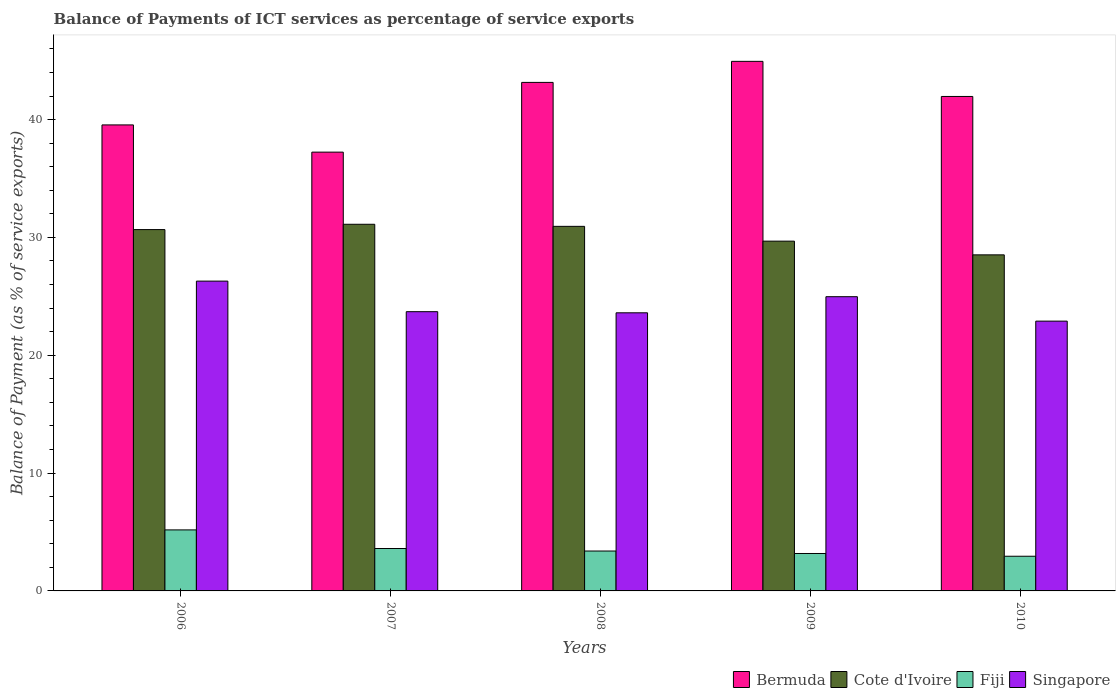How many different coloured bars are there?
Make the answer very short. 4. Are the number of bars on each tick of the X-axis equal?
Your answer should be very brief. Yes. How many bars are there on the 1st tick from the right?
Make the answer very short. 4. What is the label of the 1st group of bars from the left?
Provide a short and direct response. 2006. In how many cases, is the number of bars for a given year not equal to the number of legend labels?
Your answer should be compact. 0. What is the balance of payments of ICT services in Singapore in 2010?
Your response must be concise. 22.9. Across all years, what is the maximum balance of payments of ICT services in Cote d'Ivoire?
Give a very brief answer. 31.12. Across all years, what is the minimum balance of payments of ICT services in Fiji?
Give a very brief answer. 2.94. In which year was the balance of payments of ICT services in Singapore maximum?
Provide a short and direct response. 2006. What is the total balance of payments of ICT services in Fiji in the graph?
Ensure brevity in your answer.  18.28. What is the difference between the balance of payments of ICT services in Fiji in 2007 and that in 2009?
Your answer should be compact. 0.42. What is the difference between the balance of payments of ICT services in Bermuda in 2008 and the balance of payments of ICT services in Cote d'Ivoire in 2010?
Provide a succinct answer. 14.64. What is the average balance of payments of ICT services in Cote d'Ivoire per year?
Give a very brief answer. 30.19. In the year 2006, what is the difference between the balance of payments of ICT services in Cote d'Ivoire and balance of payments of ICT services in Singapore?
Your response must be concise. 4.37. In how many years, is the balance of payments of ICT services in Bermuda greater than 18 %?
Offer a terse response. 5. What is the ratio of the balance of payments of ICT services in Bermuda in 2008 to that in 2010?
Your answer should be very brief. 1.03. Is the balance of payments of ICT services in Singapore in 2006 less than that in 2007?
Give a very brief answer. No. What is the difference between the highest and the second highest balance of payments of ICT services in Cote d'Ivoire?
Offer a terse response. 0.18. What is the difference between the highest and the lowest balance of payments of ICT services in Fiji?
Give a very brief answer. 2.24. In how many years, is the balance of payments of ICT services in Singapore greater than the average balance of payments of ICT services in Singapore taken over all years?
Your response must be concise. 2. Is it the case that in every year, the sum of the balance of payments of ICT services in Singapore and balance of payments of ICT services in Bermuda is greater than the sum of balance of payments of ICT services in Cote d'Ivoire and balance of payments of ICT services in Fiji?
Offer a terse response. Yes. What does the 2nd bar from the left in 2009 represents?
Make the answer very short. Cote d'Ivoire. What does the 3rd bar from the right in 2007 represents?
Provide a short and direct response. Cote d'Ivoire. Is it the case that in every year, the sum of the balance of payments of ICT services in Fiji and balance of payments of ICT services in Singapore is greater than the balance of payments of ICT services in Cote d'Ivoire?
Ensure brevity in your answer.  No. Are all the bars in the graph horizontal?
Your response must be concise. No. What is the difference between two consecutive major ticks on the Y-axis?
Offer a very short reply. 10. Are the values on the major ticks of Y-axis written in scientific E-notation?
Make the answer very short. No. Does the graph contain any zero values?
Your response must be concise. No. Where does the legend appear in the graph?
Your response must be concise. Bottom right. How are the legend labels stacked?
Make the answer very short. Horizontal. What is the title of the graph?
Offer a very short reply. Balance of Payments of ICT services as percentage of service exports. What is the label or title of the X-axis?
Provide a succinct answer. Years. What is the label or title of the Y-axis?
Your response must be concise. Balance of Payment (as % of service exports). What is the Balance of Payment (as % of service exports) of Bermuda in 2006?
Offer a terse response. 39.55. What is the Balance of Payment (as % of service exports) of Cote d'Ivoire in 2006?
Your answer should be very brief. 30.67. What is the Balance of Payment (as % of service exports) of Fiji in 2006?
Provide a succinct answer. 5.18. What is the Balance of Payment (as % of service exports) of Singapore in 2006?
Offer a terse response. 26.29. What is the Balance of Payment (as % of service exports) of Bermuda in 2007?
Give a very brief answer. 37.24. What is the Balance of Payment (as % of service exports) of Cote d'Ivoire in 2007?
Offer a terse response. 31.12. What is the Balance of Payment (as % of service exports) in Fiji in 2007?
Provide a succinct answer. 3.6. What is the Balance of Payment (as % of service exports) of Singapore in 2007?
Keep it short and to the point. 23.7. What is the Balance of Payment (as % of service exports) of Bermuda in 2008?
Provide a short and direct response. 43.16. What is the Balance of Payment (as % of service exports) in Cote d'Ivoire in 2008?
Offer a terse response. 30.94. What is the Balance of Payment (as % of service exports) of Fiji in 2008?
Keep it short and to the point. 3.39. What is the Balance of Payment (as % of service exports) of Singapore in 2008?
Give a very brief answer. 23.6. What is the Balance of Payment (as % of service exports) in Bermuda in 2009?
Ensure brevity in your answer.  44.94. What is the Balance of Payment (as % of service exports) in Cote d'Ivoire in 2009?
Your answer should be very brief. 29.68. What is the Balance of Payment (as % of service exports) in Fiji in 2009?
Give a very brief answer. 3.18. What is the Balance of Payment (as % of service exports) of Singapore in 2009?
Your answer should be compact. 24.97. What is the Balance of Payment (as % of service exports) in Bermuda in 2010?
Offer a terse response. 41.96. What is the Balance of Payment (as % of service exports) in Cote d'Ivoire in 2010?
Make the answer very short. 28.52. What is the Balance of Payment (as % of service exports) in Fiji in 2010?
Your response must be concise. 2.94. What is the Balance of Payment (as % of service exports) of Singapore in 2010?
Provide a succinct answer. 22.9. Across all years, what is the maximum Balance of Payment (as % of service exports) in Bermuda?
Provide a short and direct response. 44.94. Across all years, what is the maximum Balance of Payment (as % of service exports) in Cote d'Ivoire?
Ensure brevity in your answer.  31.12. Across all years, what is the maximum Balance of Payment (as % of service exports) in Fiji?
Give a very brief answer. 5.18. Across all years, what is the maximum Balance of Payment (as % of service exports) of Singapore?
Your answer should be compact. 26.29. Across all years, what is the minimum Balance of Payment (as % of service exports) in Bermuda?
Make the answer very short. 37.24. Across all years, what is the minimum Balance of Payment (as % of service exports) of Cote d'Ivoire?
Give a very brief answer. 28.52. Across all years, what is the minimum Balance of Payment (as % of service exports) of Fiji?
Your answer should be compact. 2.94. Across all years, what is the minimum Balance of Payment (as % of service exports) of Singapore?
Offer a terse response. 22.9. What is the total Balance of Payment (as % of service exports) of Bermuda in the graph?
Give a very brief answer. 206.85. What is the total Balance of Payment (as % of service exports) of Cote d'Ivoire in the graph?
Make the answer very short. 150.93. What is the total Balance of Payment (as % of service exports) of Fiji in the graph?
Ensure brevity in your answer.  18.28. What is the total Balance of Payment (as % of service exports) in Singapore in the graph?
Keep it short and to the point. 121.46. What is the difference between the Balance of Payment (as % of service exports) of Bermuda in 2006 and that in 2007?
Provide a succinct answer. 2.31. What is the difference between the Balance of Payment (as % of service exports) of Cote d'Ivoire in 2006 and that in 2007?
Your answer should be compact. -0.45. What is the difference between the Balance of Payment (as % of service exports) of Fiji in 2006 and that in 2007?
Your response must be concise. 1.58. What is the difference between the Balance of Payment (as % of service exports) of Singapore in 2006 and that in 2007?
Provide a succinct answer. 2.59. What is the difference between the Balance of Payment (as % of service exports) in Bermuda in 2006 and that in 2008?
Keep it short and to the point. -3.61. What is the difference between the Balance of Payment (as % of service exports) in Cote d'Ivoire in 2006 and that in 2008?
Offer a terse response. -0.27. What is the difference between the Balance of Payment (as % of service exports) of Fiji in 2006 and that in 2008?
Make the answer very short. 1.79. What is the difference between the Balance of Payment (as % of service exports) of Singapore in 2006 and that in 2008?
Your answer should be compact. 2.69. What is the difference between the Balance of Payment (as % of service exports) of Bermuda in 2006 and that in 2009?
Keep it short and to the point. -5.39. What is the difference between the Balance of Payment (as % of service exports) of Cote d'Ivoire in 2006 and that in 2009?
Provide a succinct answer. 0.98. What is the difference between the Balance of Payment (as % of service exports) in Fiji in 2006 and that in 2009?
Your answer should be compact. 2. What is the difference between the Balance of Payment (as % of service exports) in Singapore in 2006 and that in 2009?
Provide a short and direct response. 1.32. What is the difference between the Balance of Payment (as % of service exports) of Bermuda in 2006 and that in 2010?
Your response must be concise. -2.41. What is the difference between the Balance of Payment (as % of service exports) of Cote d'Ivoire in 2006 and that in 2010?
Provide a succinct answer. 2.14. What is the difference between the Balance of Payment (as % of service exports) in Fiji in 2006 and that in 2010?
Offer a terse response. 2.24. What is the difference between the Balance of Payment (as % of service exports) of Singapore in 2006 and that in 2010?
Keep it short and to the point. 3.4. What is the difference between the Balance of Payment (as % of service exports) in Bermuda in 2007 and that in 2008?
Give a very brief answer. -5.92. What is the difference between the Balance of Payment (as % of service exports) of Cote d'Ivoire in 2007 and that in 2008?
Your answer should be compact. 0.18. What is the difference between the Balance of Payment (as % of service exports) in Fiji in 2007 and that in 2008?
Keep it short and to the point. 0.21. What is the difference between the Balance of Payment (as % of service exports) in Singapore in 2007 and that in 2008?
Keep it short and to the point. 0.1. What is the difference between the Balance of Payment (as % of service exports) in Bermuda in 2007 and that in 2009?
Your response must be concise. -7.7. What is the difference between the Balance of Payment (as % of service exports) in Cote d'Ivoire in 2007 and that in 2009?
Offer a very short reply. 1.43. What is the difference between the Balance of Payment (as % of service exports) of Fiji in 2007 and that in 2009?
Your answer should be compact. 0.42. What is the difference between the Balance of Payment (as % of service exports) of Singapore in 2007 and that in 2009?
Provide a short and direct response. -1.27. What is the difference between the Balance of Payment (as % of service exports) in Bermuda in 2007 and that in 2010?
Give a very brief answer. -4.73. What is the difference between the Balance of Payment (as % of service exports) in Cote d'Ivoire in 2007 and that in 2010?
Ensure brevity in your answer.  2.6. What is the difference between the Balance of Payment (as % of service exports) in Fiji in 2007 and that in 2010?
Provide a succinct answer. 0.66. What is the difference between the Balance of Payment (as % of service exports) of Singapore in 2007 and that in 2010?
Keep it short and to the point. 0.8. What is the difference between the Balance of Payment (as % of service exports) of Bermuda in 2008 and that in 2009?
Make the answer very short. -1.79. What is the difference between the Balance of Payment (as % of service exports) of Cote d'Ivoire in 2008 and that in 2009?
Your answer should be compact. 1.26. What is the difference between the Balance of Payment (as % of service exports) of Fiji in 2008 and that in 2009?
Your response must be concise. 0.21. What is the difference between the Balance of Payment (as % of service exports) in Singapore in 2008 and that in 2009?
Offer a very short reply. -1.37. What is the difference between the Balance of Payment (as % of service exports) in Bermuda in 2008 and that in 2010?
Provide a succinct answer. 1.19. What is the difference between the Balance of Payment (as % of service exports) of Cote d'Ivoire in 2008 and that in 2010?
Your answer should be compact. 2.42. What is the difference between the Balance of Payment (as % of service exports) in Fiji in 2008 and that in 2010?
Provide a succinct answer. 0.44. What is the difference between the Balance of Payment (as % of service exports) in Singapore in 2008 and that in 2010?
Offer a terse response. 0.71. What is the difference between the Balance of Payment (as % of service exports) of Bermuda in 2009 and that in 2010?
Give a very brief answer. 2.98. What is the difference between the Balance of Payment (as % of service exports) in Cote d'Ivoire in 2009 and that in 2010?
Keep it short and to the point. 1.16. What is the difference between the Balance of Payment (as % of service exports) of Fiji in 2009 and that in 2010?
Make the answer very short. 0.23. What is the difference between the Balance of Payment (as % of service exports) in Singapore in 2009 and that in 2010?
Provide a short and direct response. 2.07. What is the difference between the Balance of Payment (as % of service exports) of Bermuda in 2006 and the Balance of Payment (as % of service exports) of Cote d'Ivoire in 2007?
Offer a very short reply. 8.43. What is the difference between the Balance of Payment (as % of service exports) in Bermuda in 2006 and the Balance of Payment (as % of service exports) in Fiji in 2007?
Provide a succinct answer. 35.95. What is the difference between the Balance of Payment (as % of service exports) of Bermuda in 2006 and the Balance of Payment (as % of service exports) of Singapore in 2007?
Give a very brief answer. 15.85. What is the difference between the Balance of Payment (as % of service exports) in Cote d'Ivoire in 2006 and the Balance of Payment (as % of service exports) in Fiji in 2007?
Provide a short and direct response. 27.07. What is the difference between the Balance of Payment (as % of service exports) in Cote d'Ivoire in 2006 and the Balance of Payment (as % of service exports) in Singapore in 2007?
Keep it short and to the point. 6.97. What is the difference between the Balance of Payment (as % of service exports) in Fiji in 2006 and the Balance of Payment (as % of service exports) in Singapore in 2007?
Give a very brief answer. -18.52. What is the difference between the Balance of Payment (as % of service exports) in Bermuda in 2006 and the Balance of Payment (as % of service exports) in Cote d'Ivoire in 2008?
Ensure brevity in your answer.  8.61. What is the difference between the Balance of Payment (as % of service exports) of Bermuda in 2006 and the Balance of Payment (as % of service exports) of Fiji in 2008?
Your answer should be very brief. 36.16. What is the difference between the Balance of Payment (as % of service exports) in Bermuda in 2006 and the Balance of Payment (as % of service exports) in Singapore in 2008?
Provide a succinct answer. 15.95. What is the difference between the Balance of Payment (as % of service exports) of Cote d'Ivoire in 2006 and the Balance of Payment (as % of service exports) of Fiji in 2008?
Offer a very short reply. 27.28. What is the difference between the Balance of Payment (as % of service exports) in Cote d'Ivoire in 2006 and the Balance of Payment (as % of service exports) in Singapore in 2008?
Your answer should be very brief. 7.06. What is the difference between the Balance of Payment (as % of service exports) of Fiji in 2006 and the Balance of Payment (as % of service exports) of Singapore in 2008?
Give a very brief answer. -18.42. What is the difference between the Balance of Payment (as % of service exports) of Bermuda in 2006 and the Balance of Payment (as % of service exports) of Cote d'Ivoire in 2009?
Your answer should be very brief. 9.86. What is the difference between the Balance of Payment (as % of service exports) in Bermuda in 2006 and the Balance of Payment (as % of service exports) in Fiji in 2009?
Provide a short and direct response. 36.37. What is the difference between the Balance of Payment (as % of service exports) of Bermuda in 2006 and the Balance of Payment (as % of service exports) of Singapore in 2009?
Your answer should be compact. 14.58. What is the difference between the Balance of Payment (as % of service exports) of Cote d'Ivoire in 2006 and the Balance of Payment (as % of service exports) of Fiji in 2009?
Provide a short and direct response. 27.49. What is the difference between the Balance of Payment (as % of service exports) in Cote d'Ivoire in 2006 and the Balance of Payment (as % of service exports) in Singapore in 2009?
Your response must be concise. 5.69. What is the difference between the Balance of Payment (as % of service exports) in Fiji in 2006 and the Balance of Payment (as % of service exports) in Singapore in 2009?
Your response must be concise. -19.79. What is the difference between the Balance of Payment (as % of service exports) of Bermuda in 2006 and the Balance of Payment (as % of service exports) of Cote d'Ivoire in 2010?
Your answer should be compact. 11.03. What is the difference between the Balance of Payment (as % of service exports) of Bermuda in 2006 and the Balance of Payment (as % of service exports) of Fiji in 2010?
Offer a very short reply. 36.61. What is the difference between the Balance of Payment (as % of service exports) in Bermuda in 2006 and the Balance of Payment (as % of service exports) in Singapore in 2010?
Provide a short and direct response. 16.65. What is the difference between the Balance of Payment (as % of service exports) of Cote d'Ivoire in 2006 and the Balance of Payment (as % of service exports) of Fiji in 2010?
Provide a short and direct response. 27.72. What is the difference between the Balance of Payment (as % of service exports) in Cote d'Ivoire in 2006 and the Balance of Payment (as % of service exports) in Singapore in 2010?
Offer a terse response. 7.77. What is the difference between the Balance of Payment (as % of service exports) in Fiji in 2006 and the Balance of Payment (as % of service exports) in Singapore in 2010?
Your answer should be compact. -17.72. What is the difference between the Balance of Payment (as % of service exports) of Bermuda in 2007 and the Balance of Payment (as % of service exports) of Cote d'Ivoire in 2008?
Your answer should be compact. 6.3. What is the difference between the Balance of Payment (as % of service exports) of Bermuda in 2007 and the Balance of Payment (as % of service exports) of Fiji in 2008?
Offer a terse response. 33.85. What is the difference between the Balance of Payment (as % of service exports) of Bermuda in 2007 and the Balance of Payment (as % of service exports) of Singapore in 2008?
Your answer should be compact. 13.64. What is the difference between the Balance of Payment (as % of service exports) in Cote d'Ivoire in 2007 and the Balance of Payment (as % of service exports) in Fiji in 2008?
Give a very brief answer. 27.73. What is the difference between the Balance of Payment (as % of service exports) of Cote d'Ivoire in 2007 and the Balance of Payment (as % of service exports) of Singapore in 2008?
Your answer should be compact. 7.51. What is the difference between the Balance of Payment (as % of service exports) in Fiji in 2007 and the Balance of Payment (as % of service exports) in Singapore in 2008?
Ensure brevity in your answer.  -20. What is the difference between the Balance of Payment (as % of service exports) of Bermuda in 2007 and the Balance of Payment (as % of service exports) of Cote d'Ivoire in 2009?
Make the answer very short. 7.55. What is the difference between the Balance of Payment (as % of service exports) of Bermuda in 2007 and the Balance of Payment (as % of service exports) of Fiji in 2009?
Your response must be concise. 34.06. What is the difference between the Balance of Payment (as % of service exports) in Bermuda in 2007 and the Balance of Payment (as % of service exports) in Singapore in 2009?
Give a very brief answer. 12.27. What is the difference between the Balance of Payment (as % of service exports) in Cote d'Ivoire in 2007 and the Balance of Payment (as % of service exports) in Fiji in 2009?
Your answer should be very brief. 27.94. What is the difference between the Balance of Payment (as % of service exports) of Cote d'Ivoire in 2007 and the Balance of Payment (as % of service exports) of Singapore in 2009?
Give a very brief answer. 6.15. What is the difference between the Balance of Payment (as % of service exports) of Fiji in 2007 and the Balance of Payment (as % of service exports) of Singapore in 2009?
Offer a terse response. -21.37. What is the difference between the Balance of Payment (as % of service exports) of Bermuda in 2007 and the Balance of Payment (as % of service exports) of Cote d'Ivoire in 2010?
Offer a very short reply. 8.72. What is the difference between the Balance of Payment (as % of service exports) in Bermuda in 2007 and the Balance of Payment (as % of service exports) in Fiji in 2010?
Offer a terse response. 34.3. What is the difference between the Balance of Payment (as % of service exports) in Bermuda in 2007 and the Balance of Payment (as % of service exports) in Singapore in 2010?
Keep it short and to the point. 14.34. What is the difference between the Balance of Payment (as % of service exports) of Cote d'Ivoire in 2007 and the Balance of Payment (as % of service exports) of Fiji in 2010?
Your answer should be compact. 28.17. What is the difference between the Balance of Payment (as % of service exports) in Cote d'Ivoire in 2007 and the Balance of Payment (as % of service exports) in Singapore in 2010?
Ensure brevity in your answer.  8.22. What is the difference between the Balance of Payment (as % of service exports) of Fiji in 2007 and the Balance of Payment (as % of service exports) of Singapore in 2010?
Offer a terse response. -19.3. What is the difference between the Balance of Payment (as % of service exports) in Bermuda in 2008 and the Balance of Payment (as % of service exports) in Cote d'Ivoire in 2009?
Provide a succinct answer. 13.47. What is the difference between the Balance of Payment (as % of service exports) of Bermuda in 2008 and the Balance of Payment (as % of service exports) of Fiji in 2009?
Offer a terse response. 39.98. What is the difference between the Balance of Payment (as % of service exports) in Bermuda in 2008 and the Balance of Payment (as % of service exports) in Singapore in 2009?
Your answer should be compact. 18.19. What is the difference between the Balance of Payment (as % of service exports) of Cote d'Ivoire in 2008 and the Balance of Payment (as % of service exports) of Fiji in 2009?
Provide a short and direct response. 27.76. What is the difference between the Balance of Payment (as % of service exports) in Cote d'Ivoire in 2008 and the Balance of Payment (as % of service exports) in Singapore in 2009?
Your answer should be very brief. 5.97. What is the difference between the Balance of Payment (as % of service exports) of Fiji in 2008 and the Balance of Payment (as % of service exports) of Singapore in 2009?
Offer a terse response. -21.58. What is the difference between the Balance of Payment (as % of service exports) in Bermuda in 2008 and the Balance of Payment (as % of service exports) in Cote d'Ivoire in 2010?
Your response must be concise. 14.64. What is the difference between the Balance of Payment (as % of service exports) in Bermuda in 2008 and the Balance of Payment (as % of service exports) in Fiji in 2010?
Your answer should be very brief. 40.21. What is the difference between the Balance of Payment (as % of service exports) in Bermuda in 2008 and the Balance of Payment (as % of service exports) in Singapore in 2010?
Your answer should be compact. 20.26. What is the difference between the Balance of Payment (as % of service exports) in Cote d'Ivoire in 2008 and the Balance of Payment (as % of service exports) in Fiji in 2010?
Provide a short and direct response. 28. What is the difference between the Balance of Payment (as % of service exports) of Cote d'Ivoire in 2008 and the Balance of Payment (as % of service exports) of Singapore in 2010?
Ensure brevity in your answer.  8.04. What is the difference between the Balance of Payment (as % of service exports) of Fiji in 2008 and the Balance of Payment (as % of service exports) of Singapore in 2010?
Ensure brevity in your answer.  -19.51. What is the difference between the Balance of Payment (as % of service exports) in Bermuda in 2009 and the Balance of Payment (as % of service exports) in Cote d'Ivoire in 2010?
Offer a terse response. 16.42. What is the difference between the Balance of Payment (as % of service exports) in Bermuda in 2009 and the Balance of Payment (as % of service exports) in Fiji in 2010?
Ensure brevity in your answer.  42. What is the difference between the Balance of Payment (as % of service exports) in Bermuda in 2009 and the Balance of Payment (as % of service exports) in Singapore in 2010?
Offer a very short reply. 22.05. What is the difference between the Balance of Payment (as % of service exports) of Cote d'Ivoire in 2009 and the Balance of Payment (as % of service exports) of Fiji in 2010?
Give a very brief answer. 26.74. What is the difference between the Balance of Payment (as % of service exports) of Cote d'Ivoire in 2009 and the Balance of Payment (as % of service exports) of Singapore in 2010?
Your answer should be compact. 6.79. What is the difference between the Balance of Payment (as % of service exports) in Fiji in 2009 and the Balance of Payment (as % of service exports) in Singapore in 2010?
Make the answer very short. -19.72. What is the average Balance of Payment (as % of service exports) in Bermuda per year?
Offer a terse response. 41.37. What is the average Balance of Payment (as % of service exports) in Cote d'Ivoire per year?
Offer a very short reply. 30.19. What is the average Balance of Payment (as % of service exports) of Fiji per year?
Give a very brief answer. 3.66. What is the average Balance of Payment (as % of service exports) in Singapore per year?
Keep it short and to the point. 24.29. In the year 2006, what is the difference between the Balance of Payment (as % of service exports) of Bermuda and Balance of Payment (as % of service exports) of Cote d'Ivoire?
Ensure brevity in your answer.  8.88. In the year 2006, what is the difference between the Balance of Payment (as % of service exports) of Bermuda and Balance of Payment (as % of service exports) of Fiji?
Offer a very short reply. 34.37. In the year 2006, what is the difference between the Balance of Payment (as % of service exports) in Bermuda and Balance of Payment (as % of service exports) in Singapore?
Provide a succinct answer. 13.26. In the year 2006, what is the difference between the Balance of Payment (as % of service exports) of Cote d'Ivoire and Balance of Payment (as % of service exports) of Fiji?
Give a very brief answer. 25.49. In the year 2006, what is the difference between the Balance of Payment (as % of service exports) of Cote d'Ivoire and Balance of Payment (as % of service exports) of Singapore?
Provide a short and direct response. 4.37. In the year 2006, what is the difference between the Balance of Payment (as % of service exports) in Fiji and Balance of Payment (as % of service exports) in Singapore?
Provide a succinct answer. -21.11. In the year 2007, what is the difference between the Balance of Payment (as % of service exports) of Bermuda and Balance of Payment (as % of service exports) of Cote d'Ivoire?
Your answer should be very brief. 6.12. In the year 2007, what is the difference between the Balance of Payment (as % of service exports) of Bermuda and Balance of Payment (as % of service exports) of Fiji?
Your answer should be compact. 33.64. In the year 2007, what is the difference between the Balance of Payment (as % of service exports) of Bermuda and Balance of Payment (as % of service exports) of Singapore?
Your answer should be compact. 13.54. In the year 2007, what is the difference between the Balance of Payment (as % of service exports) in Cote d'Ivoire and Balance of Payment (as % of service exports) in Fiji?
Your answer should be very brief. 27.52. In the year 2007, what is the difference between the Balance of Payment (as % of service exports) of Cote d'Ivoire and Balance of Payment (as % of service exports) of Singapore?
Provide a short and direct response. 7.42. In the year 2007, what is the difference between the Balance of Payment (as % of service exports) of Fiji and Balance of Payment (as % of service exports) of Singapore?
Provide a succinct answer. -20.1. In the year 2008, what is the difference between the Balance of Payment (as % of service exports) in Bermuda and Balance of Payment (as % of service exports) in Cote d'Ivoire?
Provide a succinct answer. 12.22. In the year 2008, what is the difference between the Balance of Payment (as % of service exports) of Bermuda and Balance of Payment (as % of service exports) of Fiji?
Keep it short and to the point. 39.77. In the year 2008, what is the difference between the Balance of Payment (as % of service exports) of Bermuda and Balance of Payment (as % of service exports) of Singapore?
Your answer should be very brief. 19.55. In the year 2008, what is the difference between the Balance of Payment (as % of service exports) in Cote d'Ivoire and Balance of Payment (as % of service exports) in Fiji?
Your response must be concise. 27.55. In the year 2008, what is the difference between the Balance of Payment (as % of service exports) of Cote d'Ivoire and Balance of Payment (as % of service exports) of Singapore?
Provide a succinct answer. 7.34. In the year 2008, what is the difference between the Balance of Payment (as % of service exports) in Fiji and Balance of Payment (as % of service exports) in Singapore?
Offer a terse response. -20.22. In the year 2009, what is the difference between the Balance of Payment (as % of service exports) of Bermuda and Balance of Payment (as % of service exports) of Cote d'Ivoire?
Keep it short and to the point. 15.26. In the year 2009, what is the difference between the Balance of Payment (as % of service exports) of Bermuda and Balance of Payment (as % of service exports) of Fiji?
Offer a terse response. 41.77. In the year 2009, what is the difference between the Balance of Payment (as % of service exports) of Bermuda and Balance of Payment (as % of service exports) of Singapore?
Ensure brevity in your answer.  19.97. In the year 2009, what is the difference between the Balance of Payment (as % of service exports) of Cote d'Ivoire and Balance of Payment (as % of service exports) of Fiji?
Ensure brevity in your answer.  26.51. In the year 2009, what is the difference between the Balance of Payment (as % of service exports) of Cote d'Ivoire and Balance of Payment (as % of service exports) of Singapore?
Provide a short and direct response. 4.71. In the year 2009, what is the difference between the Balance of Payment (as % of service exports) in Fiji and Balance of Payment (as % of service exports) in Singapore?
Provide a succinct answer. -21.79. In the year 2010, what is the difference between the Balance of Payment (as % of service exports) in Bermuda and Balance of Payment (as % of service exports) in Cote d'Ivoire?
Provide a short and direct response. 13.44. In the year 2010, what is the difference between the Balance of Payment (as % of service exports) of Bermuda and Balance of Payment (as % of service exports) of Fiji?
Provide a short and direct response. 39.02. In the year 2010, what is the difference between the Balance of Payment (as % of service exports) of Bermuda and Balance of Payment (as % of service exports) of Singapore?
Ensure brevity in your answer.  19.07. In the year 2010, what is the difference between the Balance of Payment (as % of service exports) of Cote d'Ivoire and Balance of Payment (as % of service exports) of Fiji?
Your response must be concise. 25.58. In the year 2010, what is the difference between the Balance of Payment (as % of service exports) of Cote d'Ivoire and Balance of Payment (as % of service exports) of Singapore?
Your answer should be compact. 5.63. In the year 2010, what is the difference between the Balance of Payment (as % of service exports) of Fiji and Balance of Payment (as % of service exports) of Singapore?
Offer a very short reply. -19.95. What is the ratio of the Balance of Payment (as % of service exports) in Bermuda in 2006 to that in 2007?
Give a very brief answer. 1.06. What is the ratio of the Balance of Payment (as % of service exports) of Cote d'Ivoire in 2006 to that in 2007?
Ensure brevity in your answer.  0.99. What is the ratio of the Balance of Payment (as % of service exports) of Fiji in 2006 to that in 2007?
Give a very brief answer. 1.44. What is the ratio of the Balance of Payment (as % of service exports) in Singapore in 2006 to that in 2007?
Offer a very short reply. 1.11. What is the ratio of the Balance of Payment (as % of service exports) in Bermuda in 2006 to that in 2008?
Keep it short and to the point. 0.92. What is the ratio of the Balance of Payment (as % of service exports) of Fiji in 2006 to that in 2008?
Your response must be concise. 1.53. What is the ratio of the Balance of Payment (as % of service exports) of Singapore in 2006 to that in 2008?
Provide a short and direct response. 1.11. What is the ratio of the Balance of Payment (as % of service exports) in Cote d'Ivoire in 2006 to that in 2009?
Offer a terse response. 1.03. What is the ratio of the Balance of Payment (as % of service exports) in Fiji in 2006 to that in 2009?
Make the answer very short. 1.63. What is the ratio of the Balance of Payment (as % of service exports) of Singapore in 2006 to that in 2009?
Offer a very short reply. 1.05. What is the ratio of the Balance of Payment (as % of service exports) in Bermuda in 2006 to that in 2010?
Your answer should be very brief. 0.94. What is the ratio of the Balance of Payment (as % of service exports) in Cote d'Ivoire in 2006 to that in 2010?
Keep it short and to the point. 1.08. What is the ratio of the Balance of Payment (as % of service exports) in Fiji in 2006 to that in 2010?
Provide a short and direct response. 1.76. What is the ratio of the Balance of Payment (as % of service exports) of Singapore in 2006 to that in 2010?
Your answer should be compact. 1.15. What is the ratio of the Balance of Payment (as % of service exports) in Bermuda in 2007 to that in 2008?
Offer a terse response. 0.86. What is the ratio of the Balance of Payment (as % of service exports) in Fiji in 2007 to that in 2008?
Make the answer very short. 1.06. What is the ratio of the Balance of Payment (as % of service exports) of Bermuda in 2007 to that in 2009?
Offer a very short reply. 0.83. What is the ratio of the Balance of Payment (as % of service exports) of Cote d'Ivoire in 2007 to that in 2009?
Make the answer very short. 1.05. What is the ratio of the Balance of Payment (as % of service exports) in Fiji in 2007 to that in 2009?
Your answer should be very brief. 1.13. What is the ratio of the Balance of Payment (as % of service exports) in Singapore in 2007 to that in 2009?
Provide a succinct answer. 0.95. What is the ratio of the Balance of Payment (as % of service exports) in Bermuda in 2007 to that in 2010?
Make the answer very short. 0.89. What is the ratio of the Balance of Payment (as % of service exports) in Cote d'Ivoire in 2007 to that in 2010?
Your answer should be very brief. 1.09. What is the ratio of the Balance of Payment (as % of service exports) of Fiji in 2007 to that in 2010?
Ensure brevity in your answer.  1.22. What is the ratio of the Balance of Payment (as % of service exports) in Singapore in 2007 to that in 2010?
Ensure brevity in your answer.  1.04. What is the ratio of the Balance of Payment (as % of service exports) in Bermuda in 2008 to that in 2009?
Keep it short and to the point. 0.96. What is the ratio of the Balance of Payment (as % of service exports) of Cote d'Ivoire in 2008 to that in 2009?
Make the answer very short. 1.04. What is the ratio of the Balance of Payment (as % of service exports) of Fiji in 2008 to that in 2009?
Your answer should be compact. 1.07. What is the ratio of the Balance of Payment (as % of service exports) in Singapore in 2008 to that in 2009?
Your answer should be compact. 0.95. What is the ratio of the Balance of Payment (as % of service exports) of Bermuda in 2008 to that in 2010?
Give a very brief answer. 1.03. What is the ratio of the Balance of Payment (as % of service exports) in Cote d'Ivoire in 2008 to that in 2010?
Give a very brief answer. 1.08. What is the ratio of the Balance of Payment (as % of service exports) in Fiji in 2008 to that in 2010?
Your answer should be compact. 1.15. What is the ratio of the Balance of Payment (as % of service exports) of Singapore in 2008 to that in 2010?
Offer a very short reply. 1.03. What is the ratio of the Balance of Payment (as % of service exports) of Bermuda in 2009 to that in 2010?
Your answer should be very brief. 1.07. What is the ratio of the Balance of Payment (as % of service exports) in Cote d'Ivoire in 2009 to that in 2010?
Your answer should be very brief. 1.04. What is the ratio of the Balance of Payment (as % of service exports) in Fiji in 2009 to that in 2010?
Your answer should be very brief. 1.08. What is the ratio of the Balance of Payment (as % of service exports) in Singapore in 2009 to that in 2010?
Keep it short and to the point. 1.09. What is the difference between the highest and the second highest Balance of Payment (as % of service exports) in Bermuda?
Give a very brief answer. 1.79. What is the difference between the highest and the second highest Balance of Payment (as % of service exports) of Cote d'Ivoire?
Give a very brief answer. 0.18. What is the difference between the highest and the second highest Balance of Payment (as % of service exports) in Fiji?
Offer a terse response. 1.58. What is the difference between the highest and the second highest Balance of Payment (as % of service exports) of Singapore?
Provide a succinct answer. 1.32. What is the difference between the highest and the lowest Balance of Payment (as % of service exports) of Bermuda?
Make the answer very short. 7.7. What is the difference between the highest and the lowest Balance of Payment (as % of service exports) of Cote d'Ivoire?
Your answer should be compact. 2.6. What is the difference between the highest and the lowest Balance of Payment (as % of service exports) of Fiji?
Keep it short and to the point. 2.24. What is the difference between the highest and the lowest Balance of Payment (as % of service exports) in Singapore?
Provide a short and direct response. 3.4. 